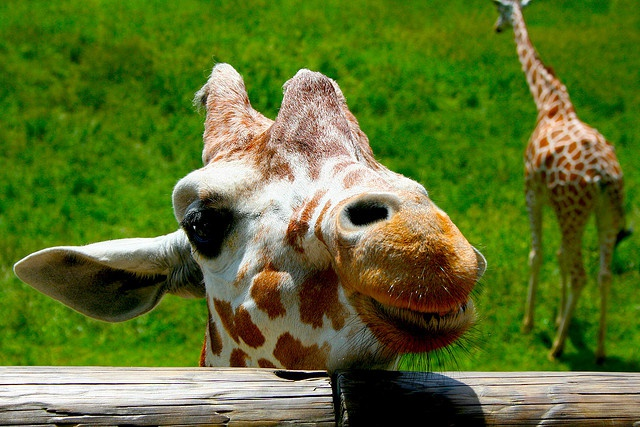Describe the objects in this image and their specific colors. I can see giraffe in darkgreen, black, lightgray, maroon, and olive tones and giraffe in darkgreen, black, and tan tones in this image. 